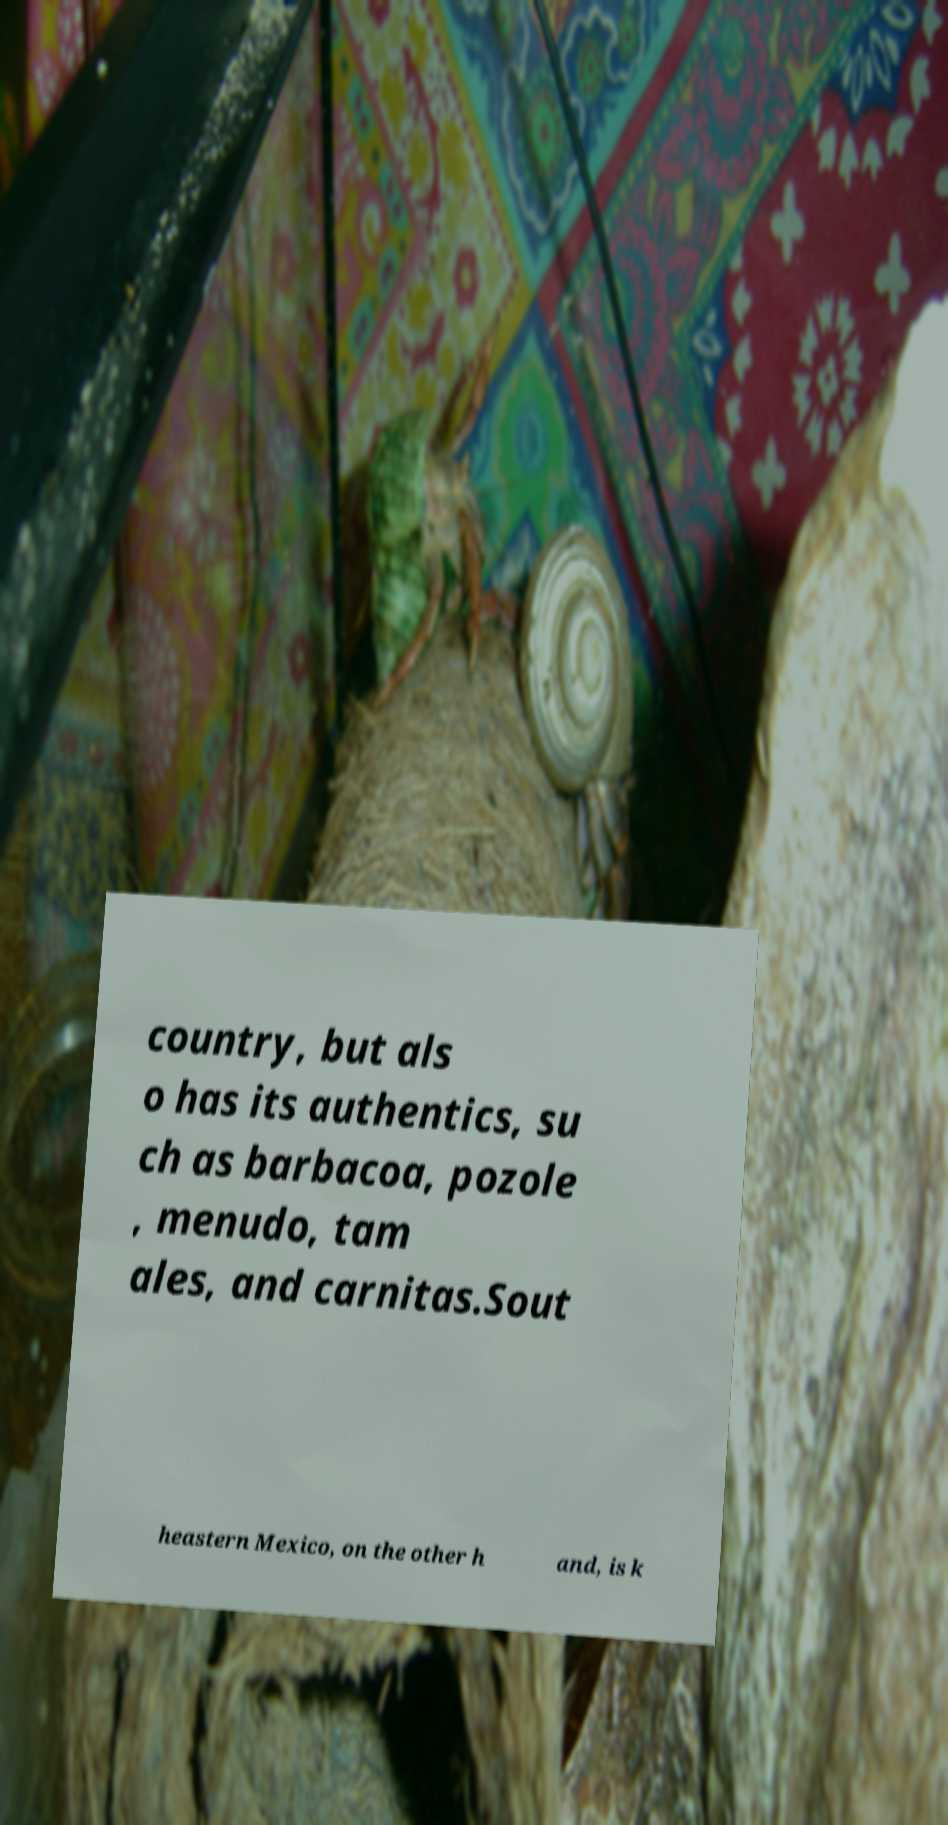Could you assist in decoding the text presented in this image and type it out clearly? country, but als o has its authentics, su ch as barbacoa, pozole , menudo, tam ales, and carnitas.Sout heastern Mexico, on the other h and, is k 